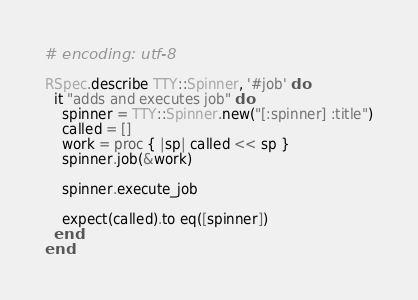Convert code to text. <code><loc_0><loc_0><loc_500><loc_500><_Ruby_># encoding: utf-8

RSpec.describe TTY::Spinner, '#job' do
  it "adds and executes job" do
    spinner = TTY::Spinner.new("[:spinner] :title")
    called = []
    work = proc { |sp| called << sp }
    spinner.job(&work)

    spinner.execute_job

    expect(called).to eq([spinner])
  end
end
</code> 